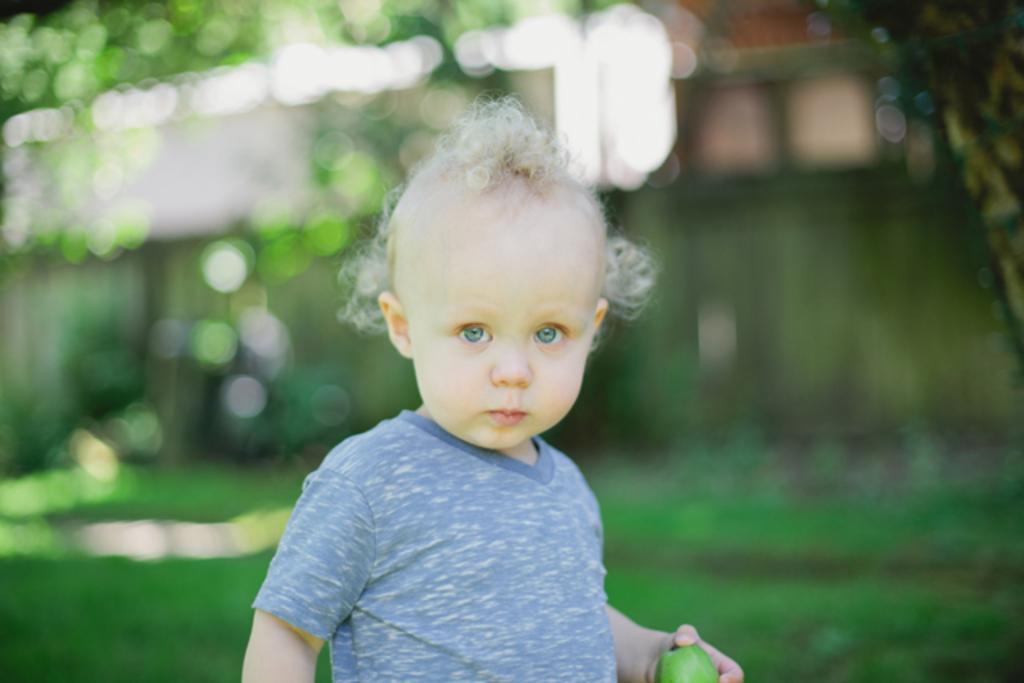Describe this image in one or two sentences. In this image there is one kid is holding a fruit as we can see in the bottom of this image. 